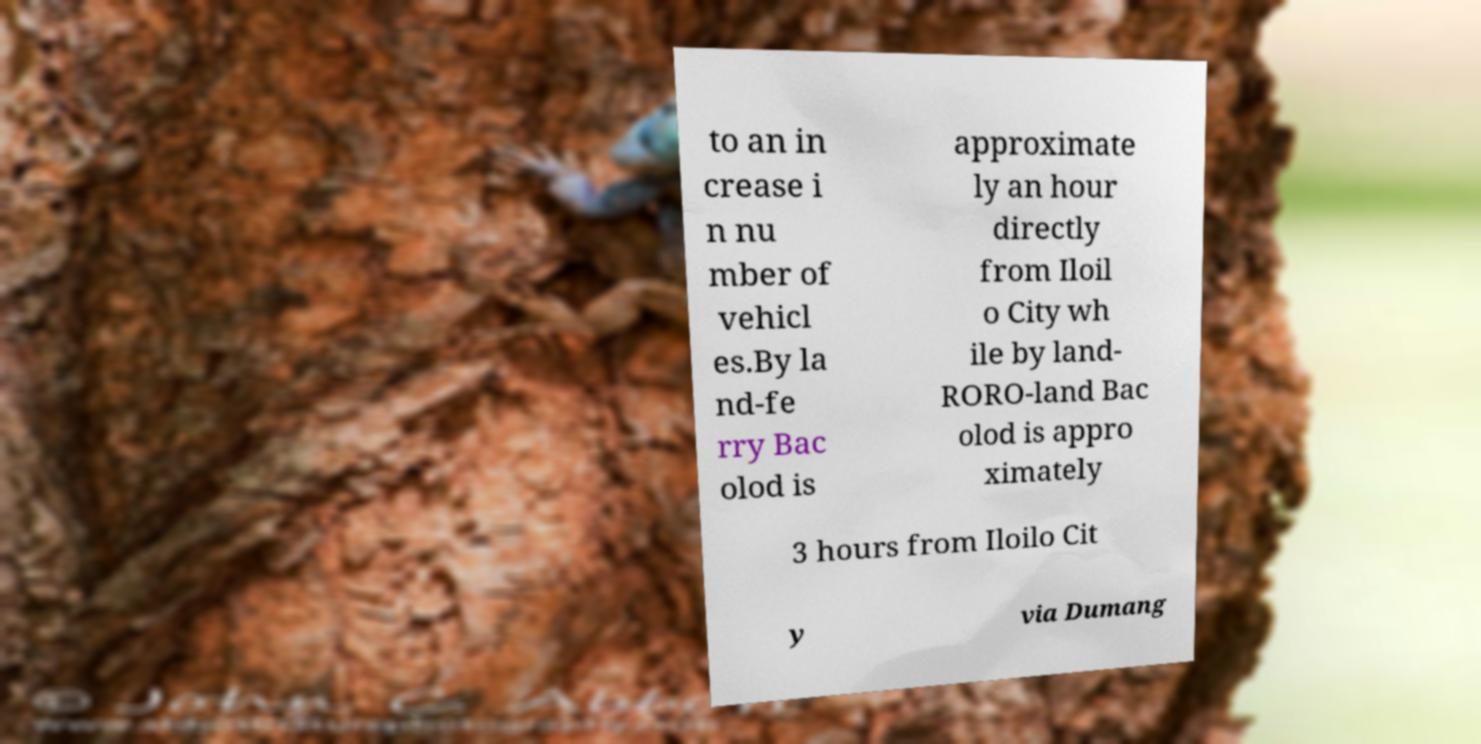There's text embedded in this image that I need extracted. Can you transcribe it verbatim? to an in crease i n nu mber of vehicl es.By la nd-fe rry Bac olod is approximate ly an hour directly from Iloil o City wh ile by land- RORO-land Bac olod is appro ximately 3 hours from Iloilo Cit y via Dumang 